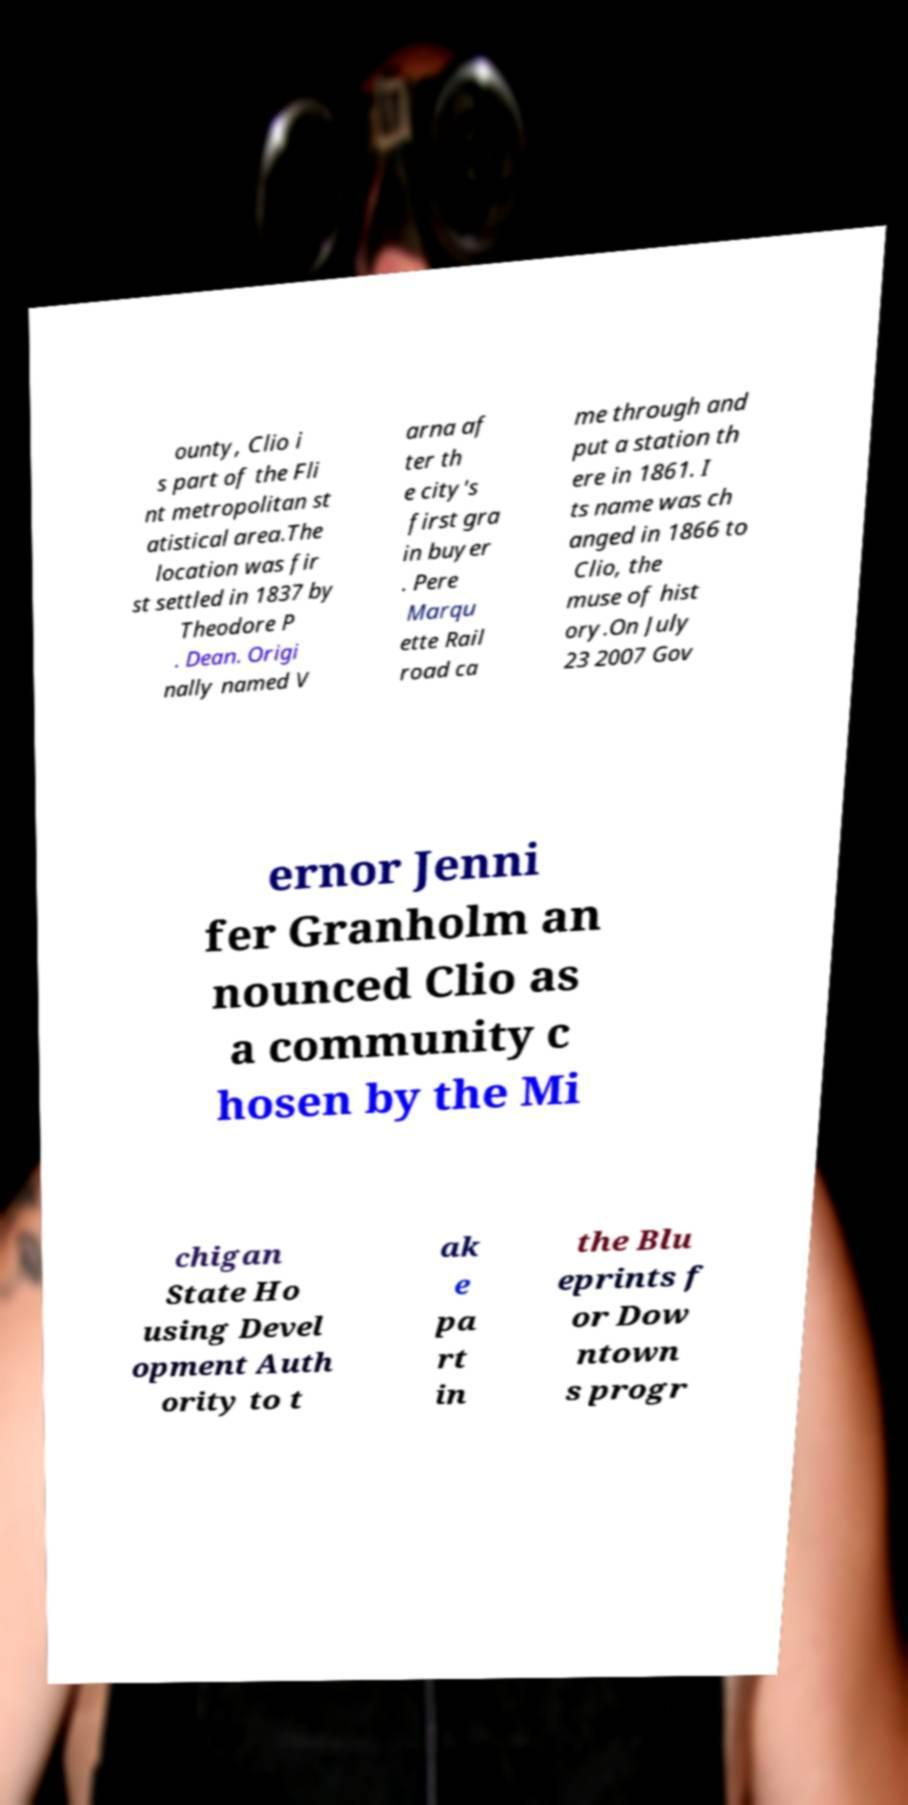Could you assist in decoding the text presented in this image and type it out clearly? ounty, Clio i s part of the Fli nt metropolitan st atistical area.The location was fir st settled in 1837 by Theodore P . Dean. Origi nally named V arna af ter th e city's first gra in buyer . Pere Marqu ette Rail road ca me through and put a station th ere in 1861. I ts name was ch anged in 1866 to Clio, the muse of hist ory.On July 23 2007 Gov ernor Jenni fer Granholm an nounced Clio as a community c hosen by the Mi chigan State Ho using Devel opment Auth ority to t ak e pa rt in the Blu eprints f or Dow ntown s progr 